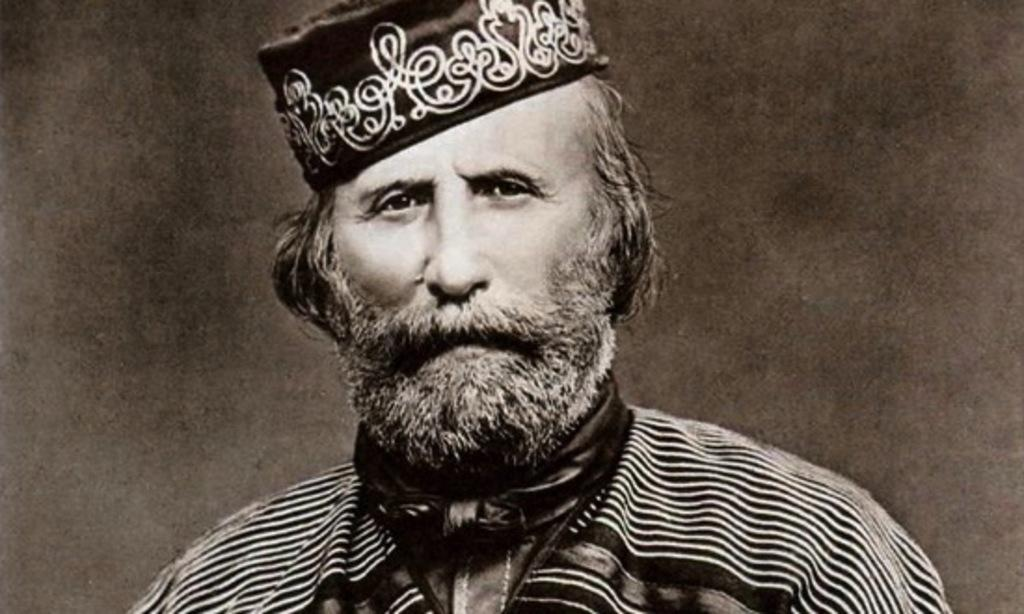What type of image is present in the picture? The image contains a black and white photograph. What is the subject of the photograph? The photograph depicts a man. What color is the man's toothpaste in the image? There is no toothpaste present in the image, as it is a black and white photograph of a man. 